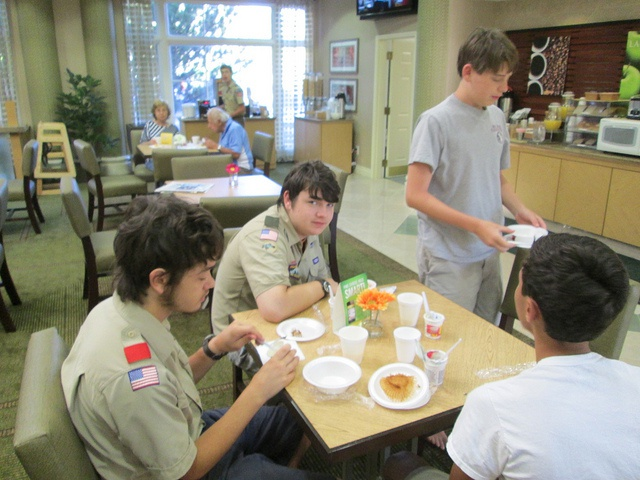Describe the objects in this image and their specific colors. I can see people in gray, black, and darkgray tones, people in gray, lightgray, and black tones, dining table in gray, tan, and lightgray tones, people in gray, darkgray, and tan tones, and people in gray, darkgray, tan, and beige tones in this image. 